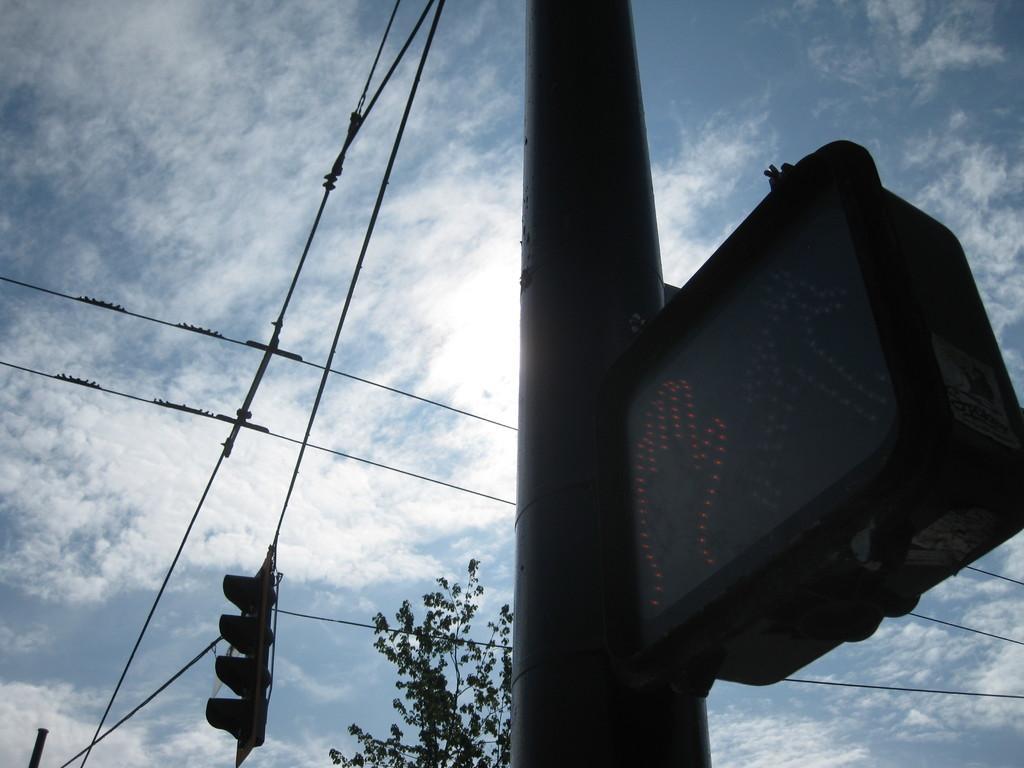How would you summarize this image in a sentence or two? In this image we can see a pole with display board on it. In the background, we can see traffic lights with some cables ,tree and the cloudy sky. 